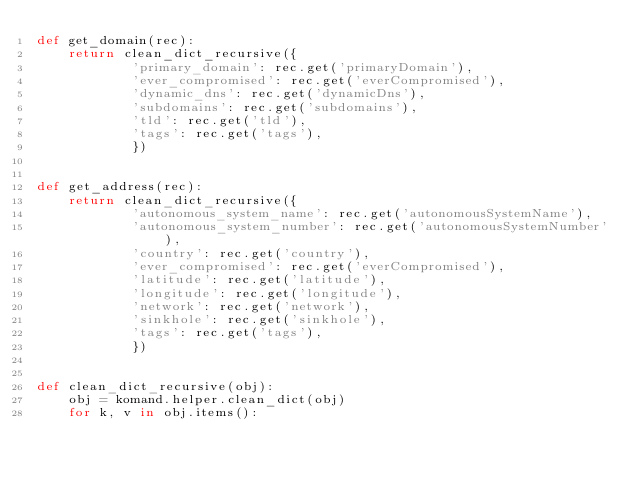Convert code to text. <code><loc_0><loc_0><loc_500><loc_500><_Python_>def get_domain(rec):
    return clean_dict_recursive({
            'primary_domain': rec.get('primaryDomain'),
            'ever_compromised': rec.get('everCompromised'),
            'dynamic_dns': rec.get('dynamicDns'),
            'subdomains': rec.get('subdomains'),
            'tld': rec.get('tld'),
            'tags': rec.get('tags'),
            })


def get_address(rec):
    return clean_dict_recursive({
            'autonomous_system_name': rec.get('autonomousSystemName'),
            'autonomous_system_number': rec.get('autonomousSystemNumber'),
            'country': rec.get('country'),
            'ever_compromised': rec.get('everCompromised'),
            'latitude': rec.get('latitude'),
            'longitude': rec.get('longitude'),
            'network': rec.get('network'),
            'sinkhole': rec.get('sinkhole'),
            'tags': rec.get('tags'),
            })


def clean_dict_recursive(obj):
    obj = komand.helper.clean_dict(obj)
    for k, v in obj.items():</code> 